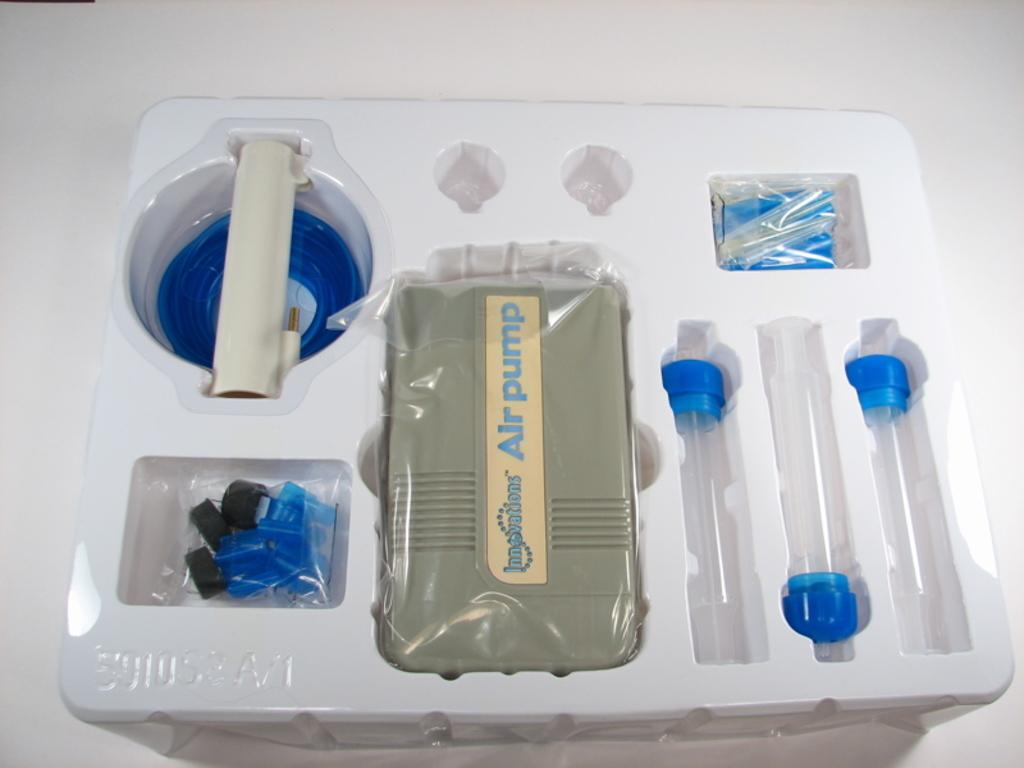What is the main object in the image? There is a white plastic box in the image. What can be found inside the box? The box contains many things. What type of cub is playing with the box in the image? There is no cub or any animal present in the image; it only features a white plastic box. What is the topic of the argument taking place near the box in the image? There is no argument or any indication of a discussion in the image; it only features a white plastic box containing many things. 